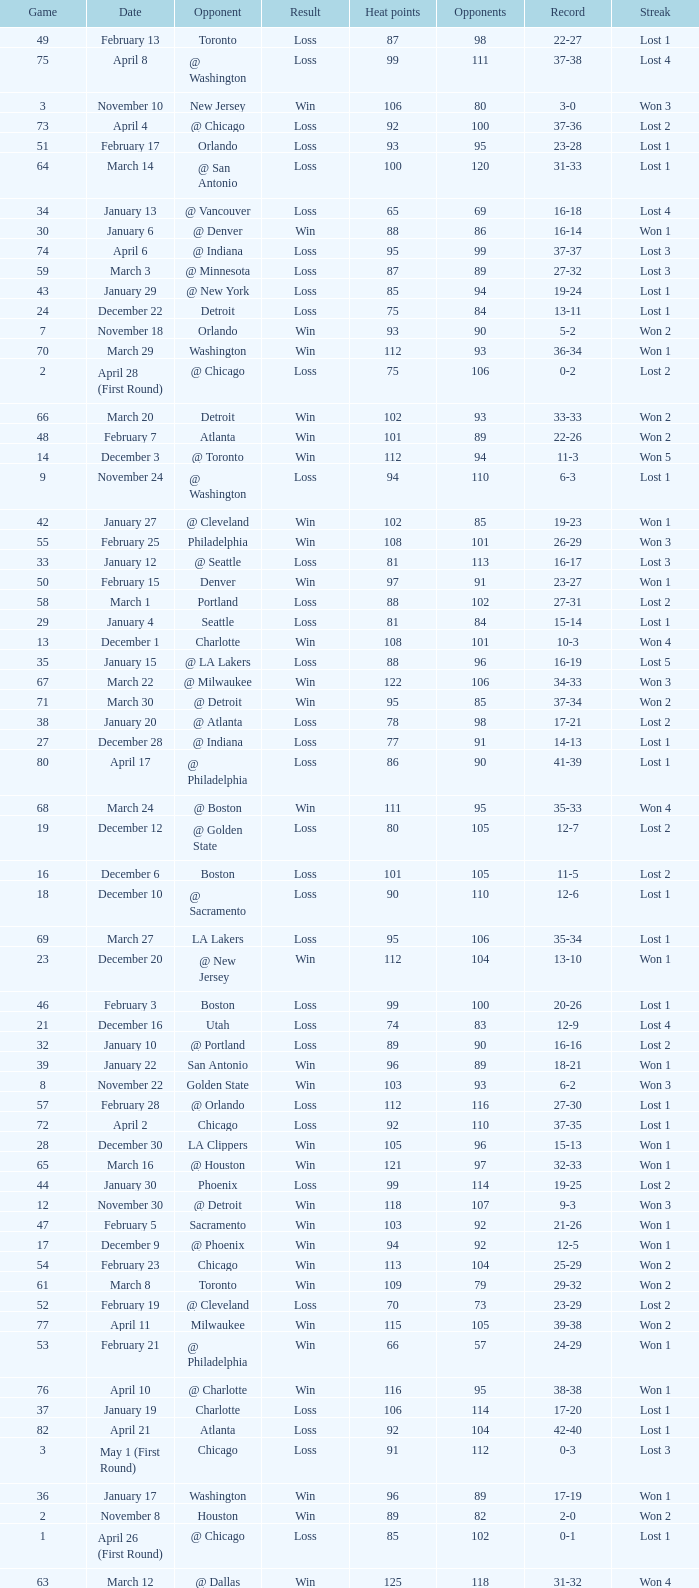What is Streak, when Heat Points is "101", and when Game is "16"? Lost 2. 